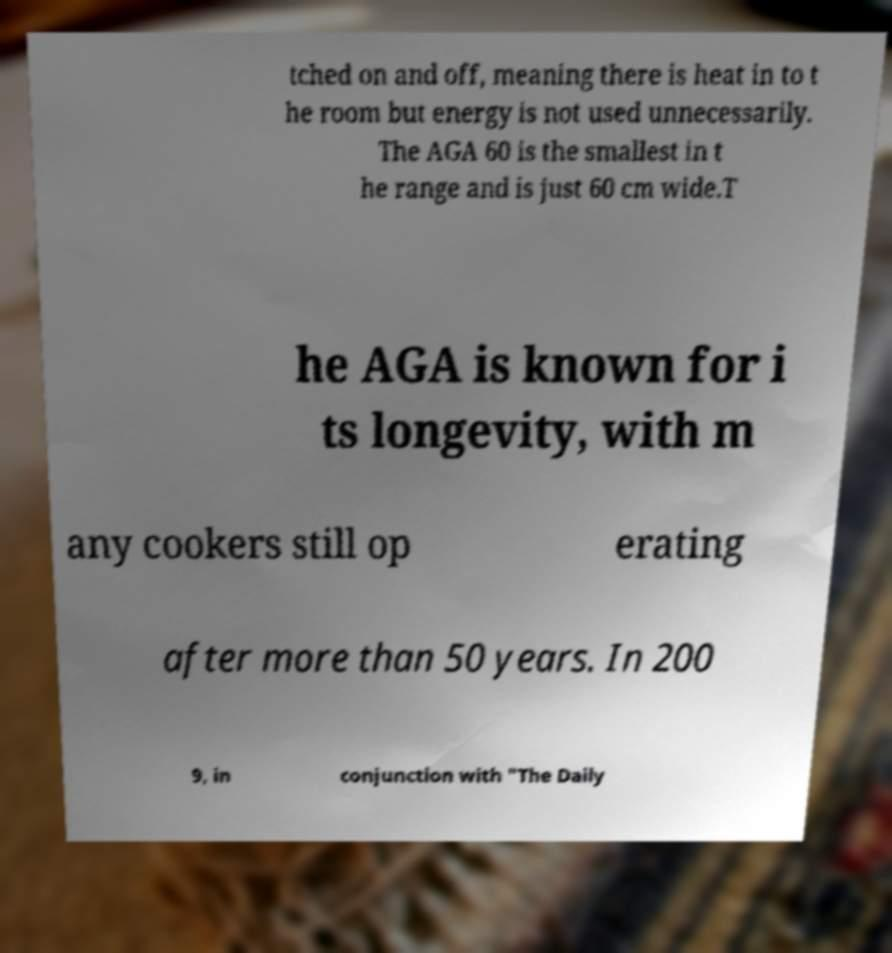I need the written content from this picture converted into text. Can you do that? tched on and off, meaning there is heat in to t he room but energy is not used unnecessarily. The AGA 60 is the smallest in t he range and is just 60 cm wide.T he AGA is known for i ts longevity, with m any cookers still op erating after more than 50 years. In 200 9, in conjunction with "The Daily 